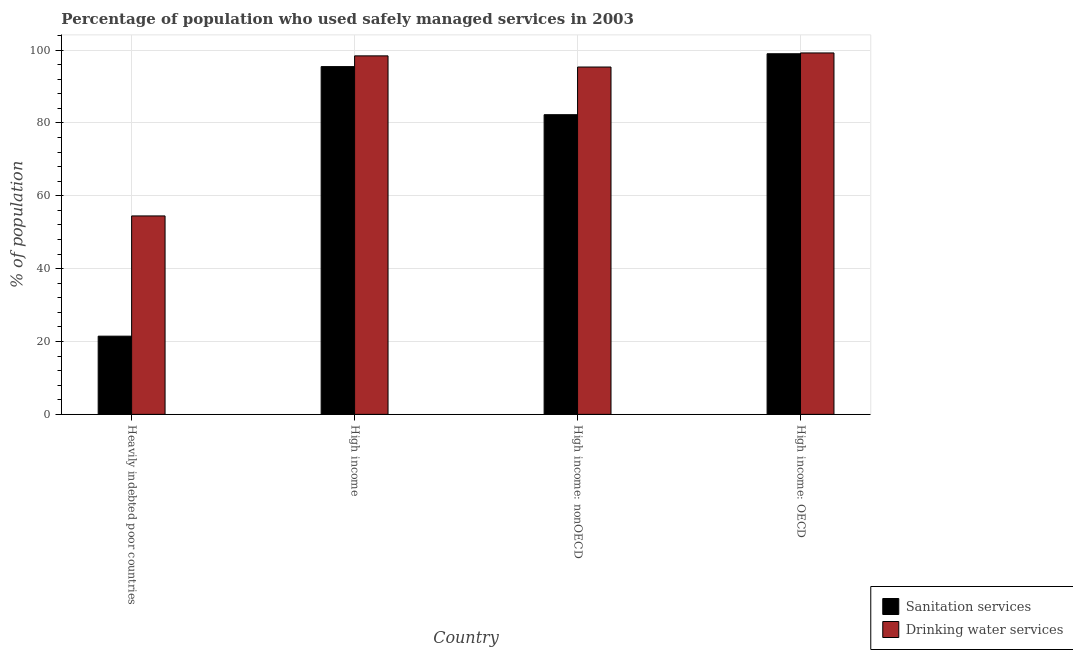How many groups of bars are there?
Offer a very short reply. 4. Are the number of bars per tick equal to the number of legend labels?
Make the answer very short. Yes. How many bars are there on the 3rd tick from the left?
Give a very brief answer. 2. How many bars are there on the 2nd tick from the right?
Offer a very short reply. 2. What is the label of the 4th group of bars from the left?
Give a very brief answer. High income: OECD. In how many cases, is the number of bars for a given country not equal to the number of legend labels?
Provide a short and direct response. 0. What is the percentage of population who used drinking water services in High income: nonOECD?
Offer a very short reply. 95.33. Across all countries, what is the maximum percentage of population who used sanitation services?
Provide a short and direct response. 98.98. Across all countries, what is the minimum percentage of population who used drinking water services?
Ensure brevity in your answer.  54.46. In which country was the percentage of population who used drinking water services maximum?
Offer a very short reply. High income: OECD. In which country was the percentage of population who used sanitation services minimum?
Offer a very short reply. Heavily indebted poor countries. What is the total percentage of population who used sanitation services in the graph?
Offer a very short reply. 298.14. What is the difference between the percentage of population who used drinking water services in High income and that in High income: nonOECD?
Ensure brevity in your answer.  3.06. What is the difference between the percentage of population who used sanitation services in High income: nonOECD and the percentage of population who used drinking water services in Heavily indebted poor countries?
Give a very brief answer. 27.79. What is the average percentage of population who used drinking water services per country?
Provide a short and direct response. 86.85. What is the difference between the percentage of population who used drinking water services and percentage of population who used sanitation services in High income?
Make the answer very short. 2.95. What is the ratio of the percentage of population who used sanitation services in Heavily indebted poor countries to that in High income?
Offer a very short reply. 0.22. Is the percentage of population who used drinking water services in Heavily indebted poor countries less than that in High income: nonOECD?
Keep it short and to the point. Yes. What is the difference between the highest and the second highest percentage of population who used sanitation services?
Offer a very short reply. 3.53. What is the difference between the highest and the lowest percentage of population who used drinking water services?
Offer a terse response. 44.73. In how many countries, is the percentage of population who used sanitation services greater than the average percentage of population who used sanitation services taken over all countries?
Keep it short and to the point. 3. Is the sum of the percentage of population who used drinking water services in Heavily indebted poor countries and High income: OECD greater than the maximum percentage of population who used sanitation services across all countries?
Your answer should be compact. Yes. What does the 1st bar from the left in High income represents?
Offer a terse response. Sanitation services. What does the 2nd bar from the right in High income represents?
Offer a terse response. Sanitation services. How many bars are there?
Give a very brief answer. 8. What is the difference between two consecutive major ticks on the Y-axis?
Give a very brief answer. 20. Are the values on the major ticks of Y-axis written in scientific E-notation?
Give a very brief answer. No. Where does the legend appear in the graph?
Provide a short and direct response. Bottom right. What is the title of the graph?
Your answer should be compact. Percentage of population who used safely managed services in 2003. Does "Automatic Teller Machines" appear as one of the legend labels in the graph?
Keep it short and to the point. No. What is the label or title of the X-axis?
Keep it short and to the point. Country. What is the label or title of the Y-axis?
Keep it short and to the point. % of population. What is the % of population in Sanitation services in Heavily indebted poor countries?
Make the answer very short. 21.47. What is the % of population of Drinking water services in Heavily indebted poor countries?
Provide a short and direct response. 54.46. What is the % of population in Sanitation services in High income?
Provide a succinct answer. 95.45. What is the % of population in Drinking water services in High income?
Offer a terse response. 98.39. What is the % of population in Sanitation services in High income: nonOECD?
Give a very brief answer. 82.25. What is the % of population in Drinking water services in High income: nonOECD?
Offer a very short reply. 95.33. What is the % of population in Sanitation services in High income: OECD?
Make the answer very short. 98.98. What is the % of population of Drinking water services in High income: OECD?
Offer a terse response. 99.19. Across all countries, what is the maximum % of population of Sanitation services?
Your answer should be very brief. 98.98. Across all countries, what is the maximum % of population in Drinking water services?
Offer a terse response. 99.19. Across all countries, what is the minimum % of population of Sanitation services?
Offer a very short reply. 21.47. Across all countries, what is the minimum % of population in Drinking water services?
Your answer should be compact. 54.46. What is the total % of population in Sanitation services in the graph?
Make the answer very short. 298.14. What is the total % of population of Drinking water services in the graph?
Offer a very short reply. 347.38. What is the difference between the % of population of Sanitation services in Heavily indebted poor countries and that in High income?
Give a very brief answer. -73.98. What is the difference between the % of population in Drinking water services in Heavily indebted poor countries and that in High income?
Make the answer very short. -43.93. What is the difference between the % of population in Sanitation services in Heavily indebted poor countries and that in High income: nonOECD?
Ensure brevity in your answer.  -60.78. What is the difference between the % of population in Drinking water services in Heavily indebted poor countries and that in High income: nonOECD?
Your response must be concise. -40.87. What is the difference between the % of population of Sanitation services in Heavily indebted poor countries and that in High income: OECD?
Provide a succinct answer. -77.51. What is the difference between the % of population of Drinking water services in Heavily indebted poor countries and that in High income: OECD?
Your response must be concise. -44.73. What is the difference between the % of population in Sanitation services in High income and that in High income: nonOECD?
Ensure brevity in your answer.  13.2. What is the difference between the % of population in Drinking water services in High income and that in High income: nonOECD?
Provide a succinct answer. 3.06. What is the difference between the % of population in Sanitation services in High income and that in High income: OECD?
Your answer should be compact. -3.53. What is the difference between the % of population in Drinking water services in High income and that in High income: OECD?
Your answer should be compact. -0.8. What is the difference between the % of population in Sanitation services in High income: nonOECD and that in High income: OECD?
Give a very brief answer. -16.73. What is the difference between the % of population of Drinking water services in High income: nonOECD and that in High income: OECD?
Ensure brevity in your answer.  -3.86. What is the difference between the % of population in Sanitation services in Heavily indebted poor countries and the % of population in Drinking water services in High income?
Provide a succinct answer. -76.93. What is the difference between the % of population of Sanitation services in Heavily indebted poor countries and the % of population of Drinking water services in High income: nonOECD?
Provide a succinct answer. -73.87. What is the difference between the % of population of Sanitation services in Heavily indebted poor countries and the % of population of Drinking water services in High income: OECD?
Ensure brevity in your answer.  -77.73. What is the difference between the % of population in Sanitation services in High income and the % of population in Drinking water services in High income: nonOECD?
Offer a terse response. 0.11. What is the difference between the % of population of Sanitation services in High income and the % of population of Drinking water services in High income: OECD?
Ensure brevity in your answer.  -3.75. What is the difference between the % of population in Sanitation services in High income: nonOECD and the % of population in Drinking water services in High income: OECD?
Provide a short and direct response. -16.95. What is the average % of population of Sanitation services per country?
Give a very brief answer. 74.53. What is the average % of population in Drinking water services per country?
Your answer should be very brief. 86.85. What is the difference between the % of population of Sanitation services and % of population of Drinking water services in Heavily indebted poor countries?
Offer a very short reply. -33. What is the difference between the % of population of Sanitation services and % of population of Drinking water services in High income?
Your response must be concise. -2.95. What is the difference between the % of population of Sanitation services and % of population of Drinking water services in High income: nonOECD?
Offer a very short reply. -13.08. What is the difference between the % of population of Sanitation services and % of population of Drinking water services in High income: OECD?
Provide a short and direct response. -0.22. What is the ratio of the % of population in Sanitation services in Heavily indebted poor countries to that in High income?
Make the answer very short. 0.22. What is the ratio of the % of population of Drinking water services in Heavily indebted poor countries to that in High income?
Give a very brief answer. 0.55. What is the ratio of the % of population in Sanitation services in Heavily indebted poor countries to that in High income: nonOECD?
Your response must be concise. 0.26. What is the ratio of the % of population of Drinking water services in Heavily indebted poor countries to that in High income: nonOECD?
Provide a short and direct response. 0.57. What is the ratio of the % of population of Sanitation services in Heavily indebted poor countries to that in High income: OECD?
Offer a very short reply. 0.22. What is the ratio of the % of population of Drinking water services in Heavily indebted poor countries to that in High income: OECD?
Provide a short and direct response. 0.55. What is the ratio of the % of population of Sanitation services in High income to that in High income: nonOECD?
Provide a short and direct response. 1.16. What is the ratio of the % of population in Drinking water services in High income to that in High income: nonOECD?
Your answer should be very brief. 1.03. What is the ratio of the % of population of Sanitation services in High income: nonOECD to that in High income: OECD?
Your response must be concise. 0.83. What is the ratio of the % of population of Drinking water services in High income: nonOECD to that in High income: OECD?
Your response must be concise. 0.96. What is the difference between the highest and the second highest % of population in Sanitation services?
Your answer should be compact. 3.53. What is the difference between the highest and the second highest % of population in Drinking water services?
Keep it short and to the point. 0.8. What is the difference between the highest and the lowest % of population in Sanitation services?
Provide a short and direct response. 77.51. What is the difference between the highest and the lowest % of population in Drinking water services?
Ensure brevity in your answer.  44.73. 